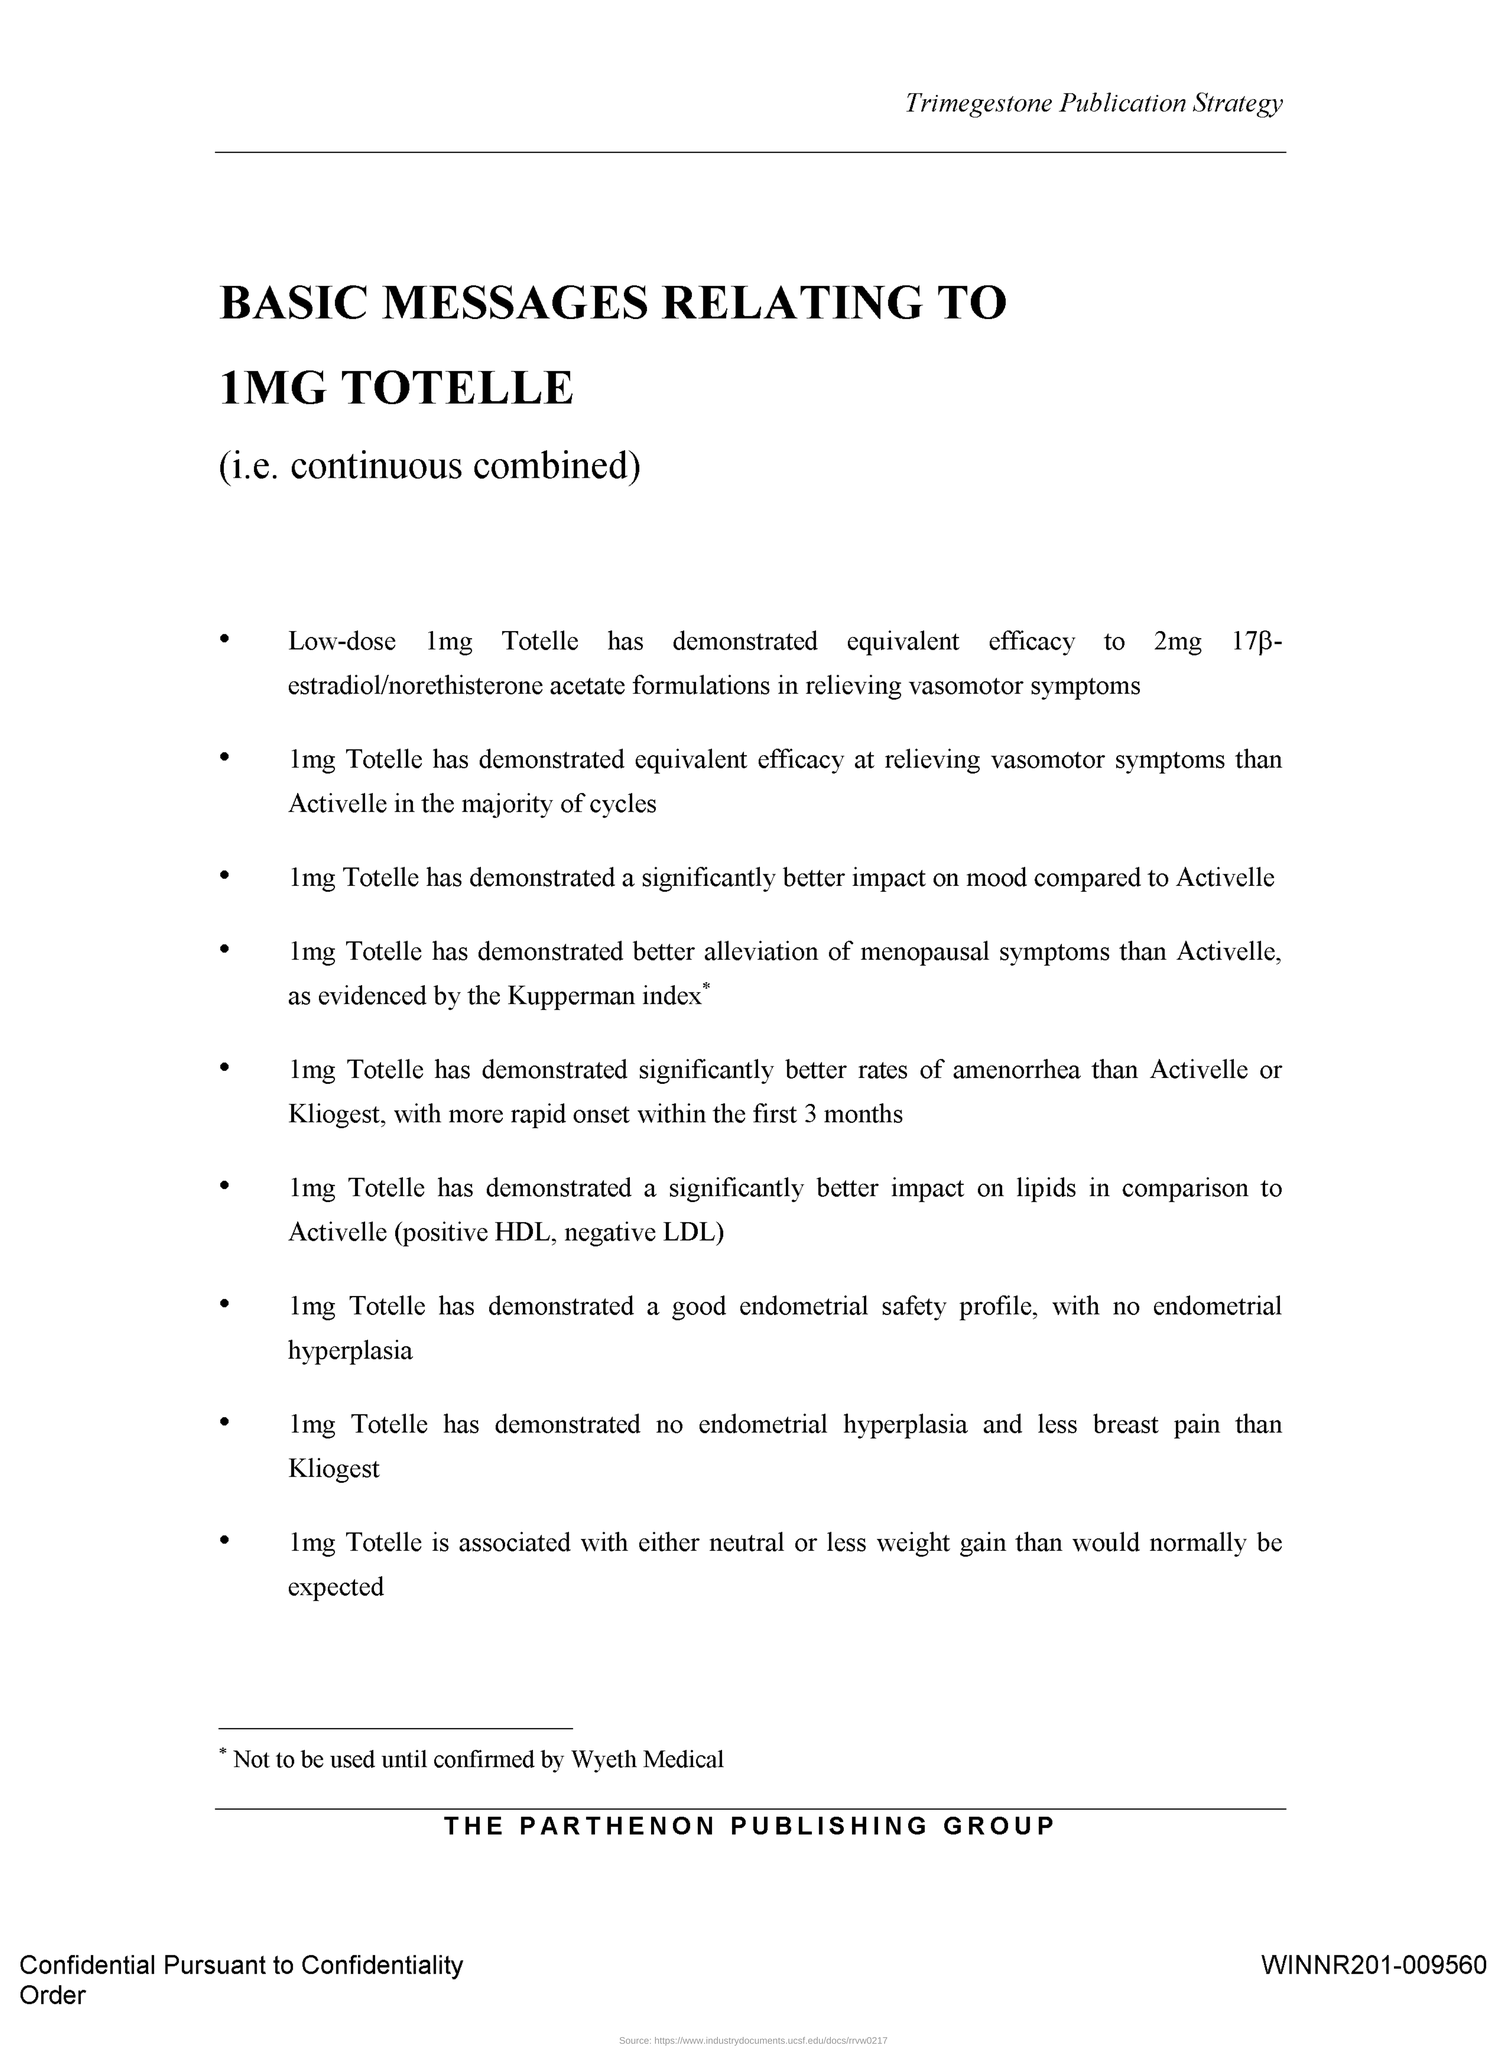What is the title written in the header of the document?
Your response must be concise. Trimegestone Publication Strategy. 